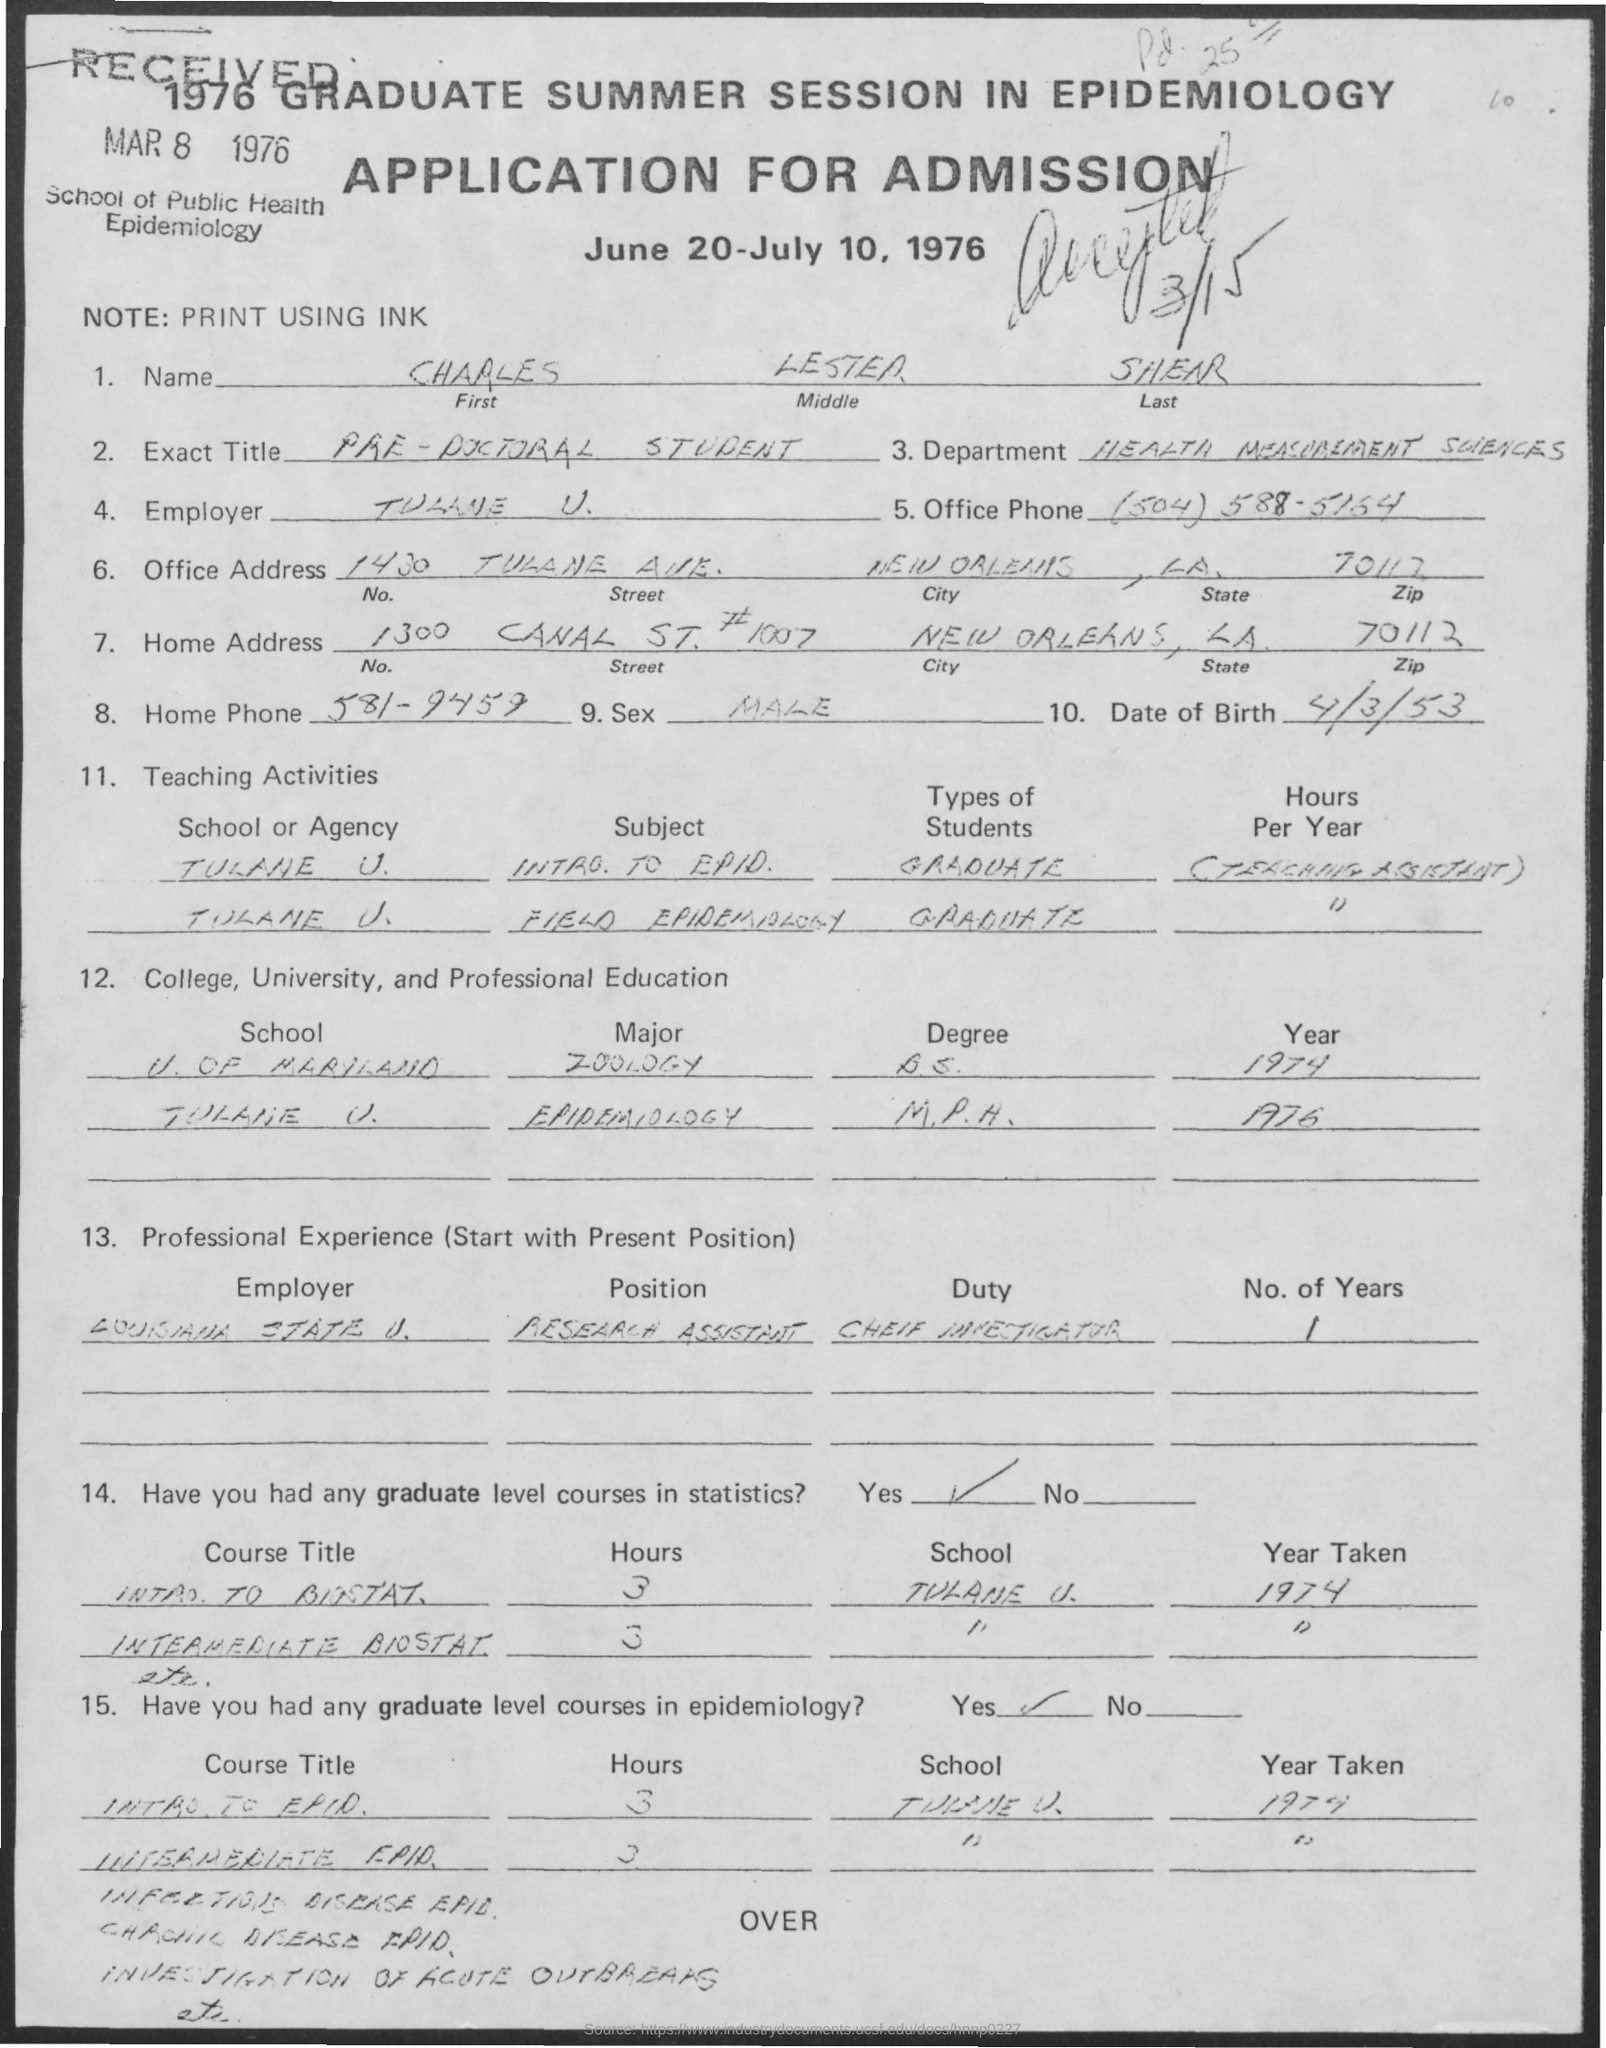On which date application was received ?
Keep it short and to the point. Mar 8, 1976. What is the note mentioned in the given application ?
Provide a short and direct response. Print using ink. What is the first name mentioned in the given application ?
Make the answer very short. Charles. What is the middle name as mentioned in the given application ?
Provide a succinct answer. Lester. What is the name of the department mentioned in the given application ?
Make the answer very short. Health measurement sciences. What is the date of birth mentioned in the given application ?
Your response must be concise. 4/3/53. What is the home phone number mentioned in the given application ?
Provide a succinct answer. 581-9459. What is the office phone number mentioned in the given application ?
Your response must be concise. (504) 588-5164. What are the dates mentioned for admission in the given application ?
Offer a terse response. June 20-July 10, 1976. 